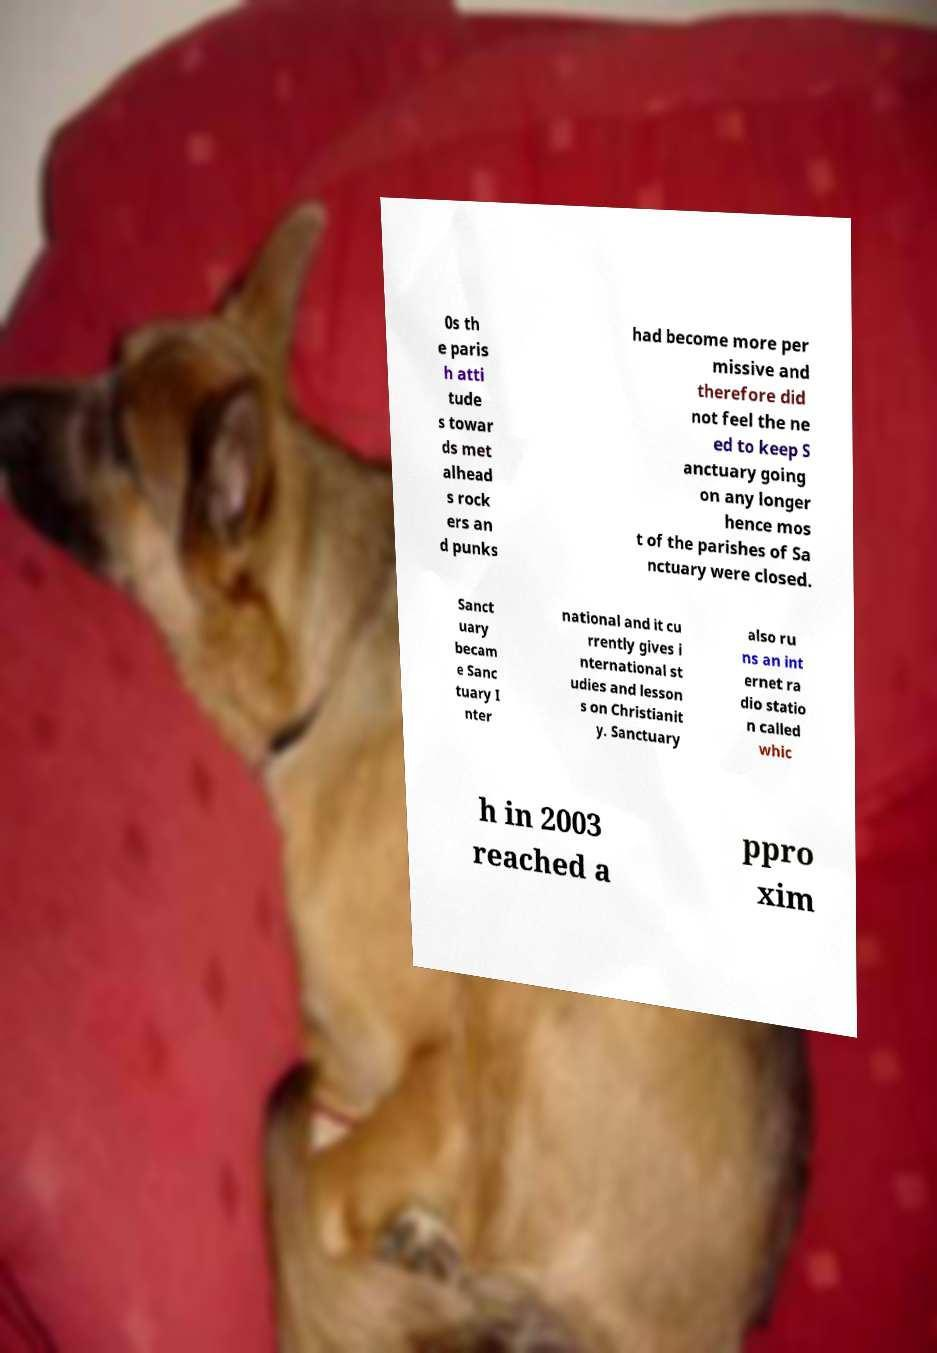For documentation purposes, I need the text within this image transcribed. Could you provide that? 0s th e paris h atti tude s towar ds met alhead s rock ers an d punks had become more per missive and therefore did not feel the ne ed to keep S anctuary going on any longer hence mos t of the parishes of Sa nctuary were closed. Sanct uary becam e Sanc tuary I nter national and it cu rrently gives i nternational st udies and lesson s on Christianit y. Sanctuary also ru ns an int ernet ra dio statio n called whic h in 2003 reached a ppro xim 